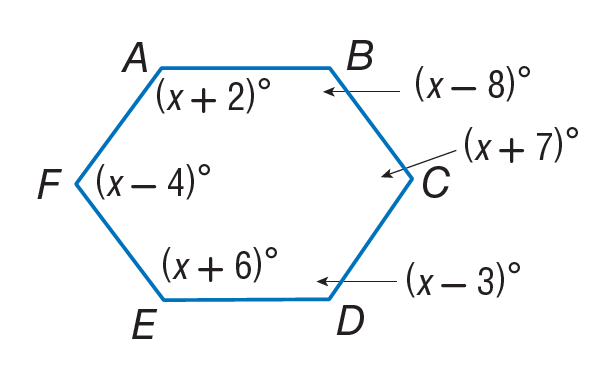Answer the mathemtical geometry problem and directly provide the correct option letter.
Question: Find m \angle A.
Choices: A: 112 B: 118 C: 120 D: 122 D 